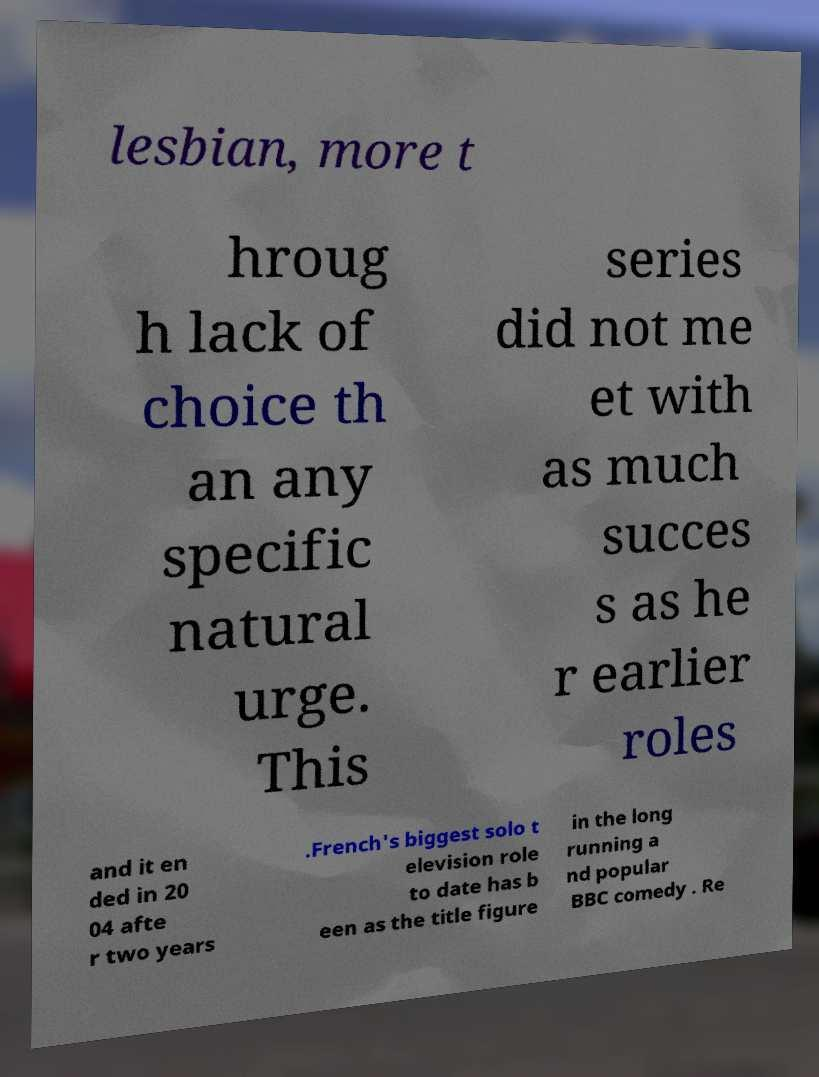Can you accurately transcribe the text from the provided image for me? lesbian, more t hroug h lack of choice th an any specific natural urge. This series did not me et with as much succes s as he r earlier roles and it en ded in 20 04 afte r two years .French's biggest solo t elevision role to date has b een as the title figure in the long running a nd popular BBC comedy . Re 